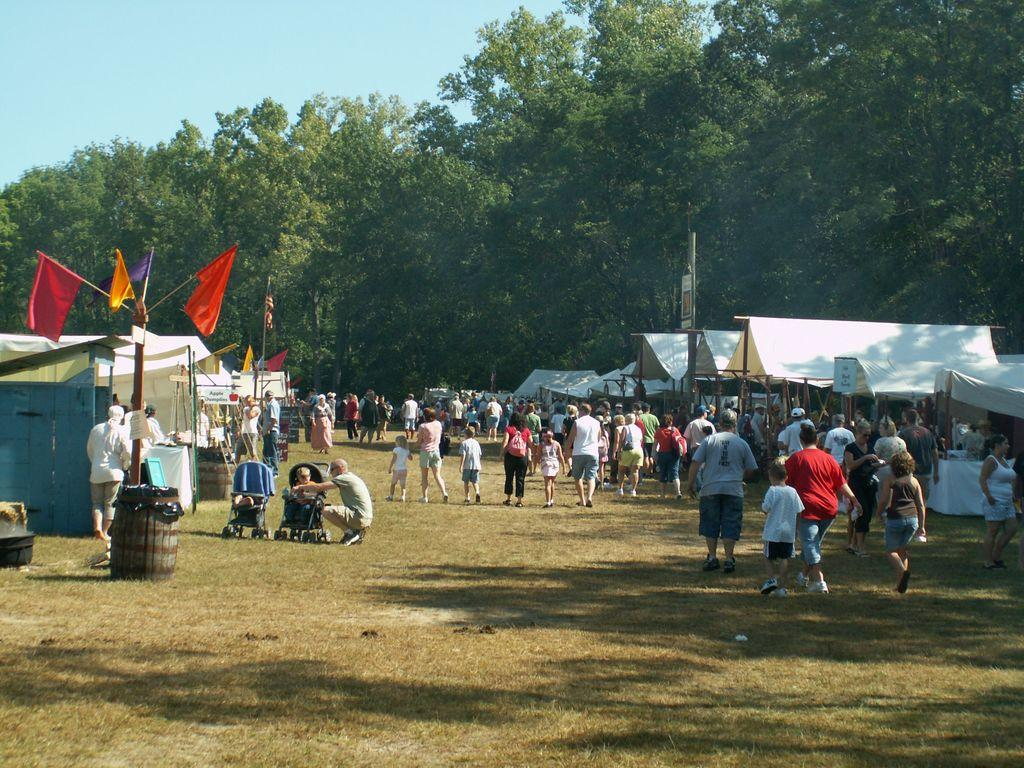What are the people in the image doing? The people in the image are walking on the ground. What objects can be seen in the image besides people? There are barrels, baby chairs, tents, boards, and flags visible in the image. What type of furniture is present in the image? Baby chairs are present in the image. What type of structures can be seen in the image? Tents are visible in the image. What type of objects are used for display or decoration? Flags are present in the image. What type of natural elements are visible in the image? Trees are visible in the image. What is visible in the background of the image? The sky is visible in the background of the image. What type of lace is draped over the trees in the image? There is no lace present in the image; only trees, people, barrels, baby chairs, tents, boards, flags, and the sky are visible. 